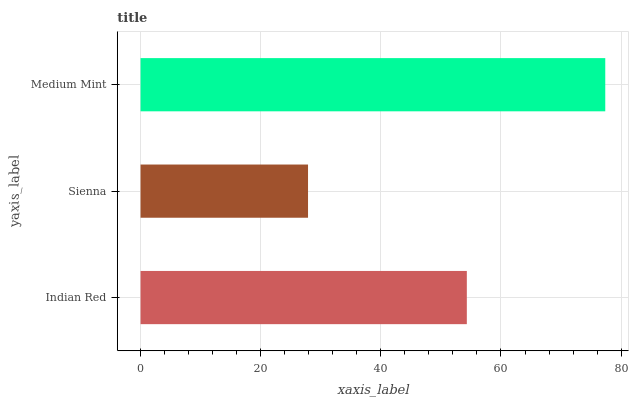Is Sienna the minimum?
Answer yes or no. Yes. Is Medium Mint the maximum?
Answer yes or no. Yes. Is Medium Mint the minimum?
Answer yes or no. No. Is Sienna the maximum?
Answer yes or no. No. Is Medium Mint greater than Sienna?
Answer yes or no. Yes. Is Sienna less than Medium Mint?
Answer yes or no. Yes. Is Sienna greater than Medium Mint?
Answer yes or no. No. Is Medium Mint less than Sienna?
Answer yes or no. No. Is Indian Red the high median?
Answer yes or no. Yes. Is Indian Red the low median?
Answer yes or no. Yes. Is Medium Mint the high median?
Answer yes or no. No. Is Sienna the low median?
Answer yes or no. No. 